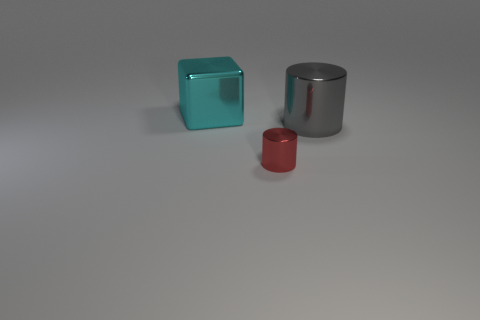What is the size of the cyan object that is made of the same material as the tiny red cylinder? large 